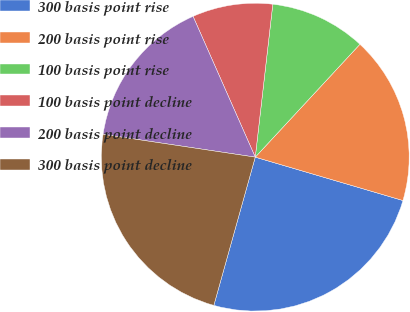<chart> <loc_0><loc_0><loc_500><loc_500><pie_chart><fcel>300 basis point rise<fcel>200 basis point rise<fcel>100 basis point rise<fcel>100 basis point decline<fcel>200 basis point decline<fcel>300 basis point decline<nl><fcel>24.79%<fcel>17.65%<fcel>10.08%<fcel>8.44%<fcel>16.01%<fcel>23.03%<nl></chart> 